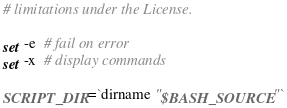Convert code to text. <code><loc_0><loc_0><loc_500><loc_500><_Bash_># limitations under the License.

set -e  # fail on error
set -x  # display commands

SCRIPT_DIR=`dirname "$BASH_SOURCE"`</code> 